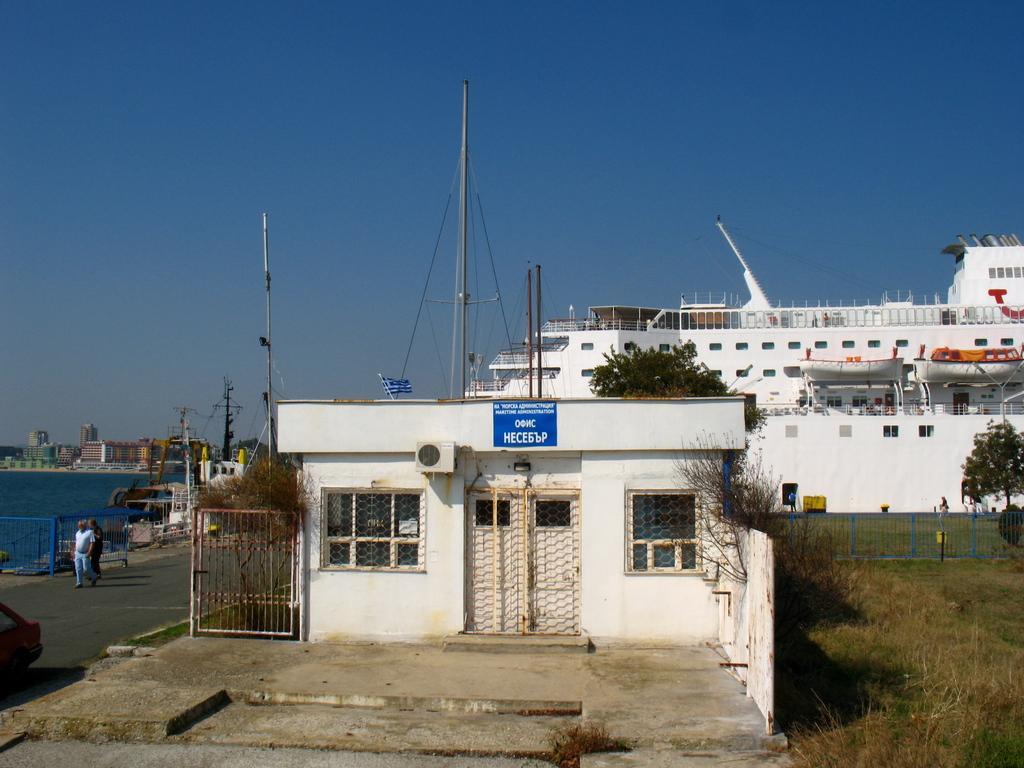Could you give a brief overview of what you see in this image? In this image I can see a building in the centre and on it I can see a blue colour board. I can also see something is written on the board. I can also see two windows, doors, an iron gate and a plant. On the right side of this image I can see an open grass ground, iron fencing, number of trees and one person. On the left side I can see a road and on it I can see a car and two persons. In the background I can see water, number of buildings, a white colour ship, few poles and the sky. 